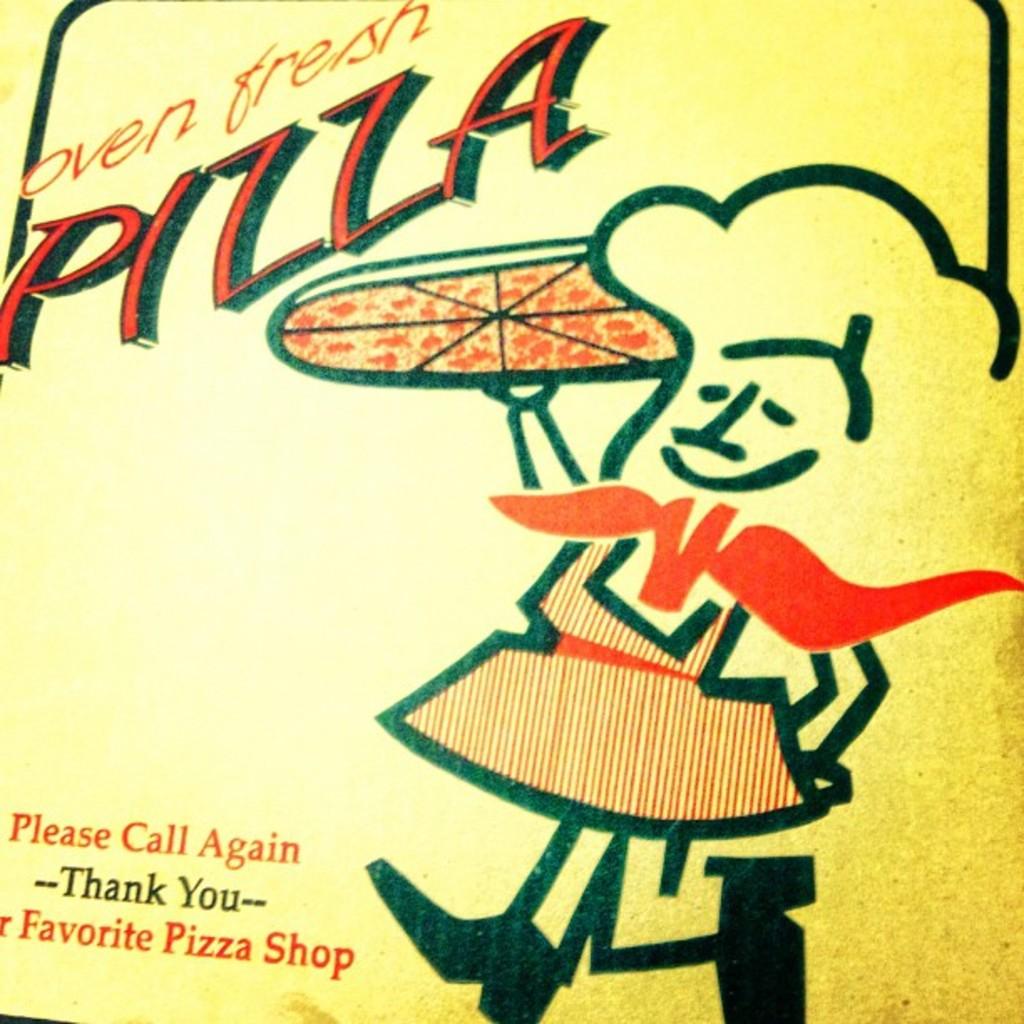How fresh is the pizza?
Keep it short and to the point. Oven fresh. What was used to make this pizza fresh?
Ensure brevity in your answer.  Oven. 